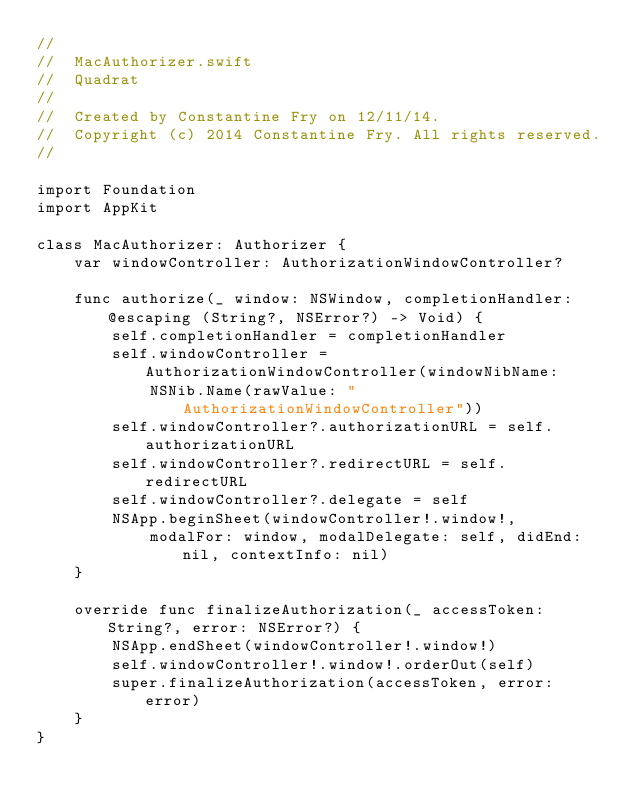Convert code to text. <code><loc_0><loc_0><loc_500><loc_500><_Swift_>//
//  MacAuthorizer.swift
//  Quadrat
//
//  Created by Constantine Fry on 12/11/14.
//  Copyright (c) 2014 Constantine Fry. All rights reserved.
//

import Foundation
import AppKit

class MacAuthorizer: Authorizer {
    var windowController: AuthorizationWindowController?
    
    func authorize(_ window: NSWindow, completionHandler: @escaping (String?, NSError?) -> Void) {
        self.completionHandler = completionHandler
        self.windowController = AuthorizationWindowController(windowNibName:
            NSNib.Name(rawValue: "AuthorizationWindowController"))
        self.windowController?.authorizationURL = self.authorizationURL
        self.windowController?.redirectURL = self.redirectURL
        self.windowController?.delegate = self
        NSApp.beginSheet(windowController!.window!,
            modalFor: window, modalDelegate: self, didEnd: nil, contextInfo: nil)
    }
    
    override func finalizeAuthorization(_ accessToken: String?, error: NSError?) {
        NSApp.endSheet(windowController!.window!)
        self.windowController!.window!.orderOut(self)
        super.finalizeAuthorization(accessToken, error: error)
    }
}
</code> 